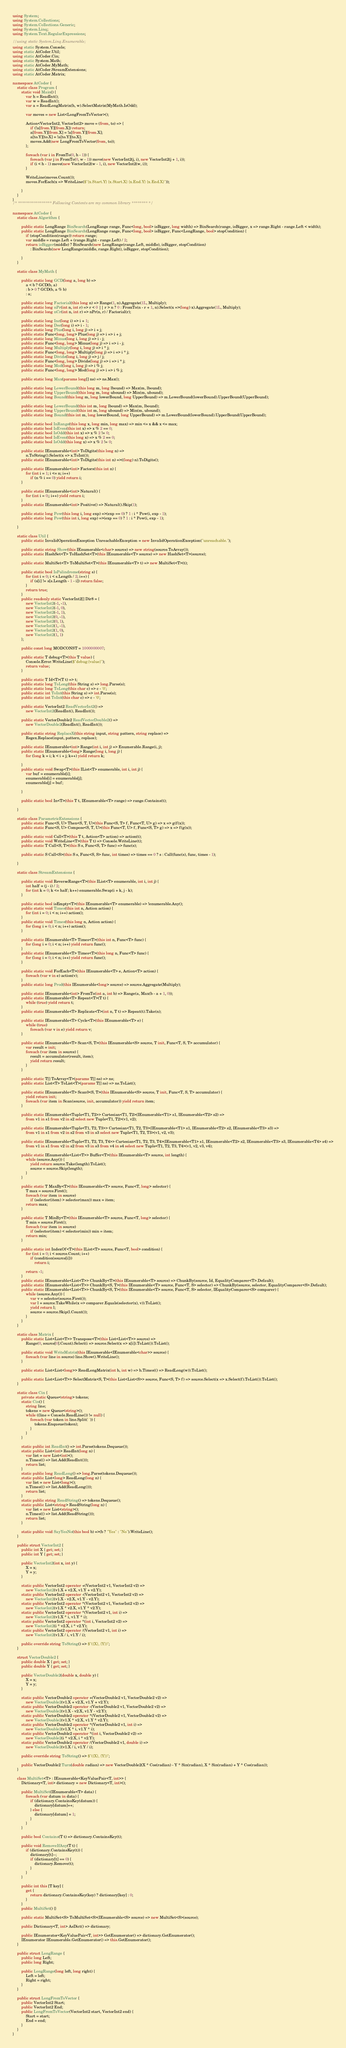<code> <loc_0><loc_0><loc_500><loc_500><_C#_>using System;
using System.Collections;
using System.Collections.Generic;
using System.Linq;
using System.Text.RegularExpressions;

//using static System.Linq.Enumerable;
using static System.Console;
using static AtCoder.Util;
using static AtCoder.Cin;
using static System.Math;
using static AtCoder.MyMath;
using static AtCoder.StreamExtensions;
using static AtCoder.Matrix;

namespace AtCoder {
    static class Program {
        static void Main() {
            var h = ReadInt();
            var w = ReadInt();
            var a = ReadLongMatrix(h, w).SelectMatrix(MyMath.IsOdd);

            var moves = new List<LongFromToVector>();

            Action<VectorInt2, VectorInt2> move = (from, to) => {
                if (!a[from.Y][from.X]) return;
                a[from.Y][from.X] = !a[from.Y][from.X];
                a[to.Y][to.X] = !a[to.Y][to.X];
                moves.Add(new LongFromToVector(from, to));
            };

            foreach (var i in FromTo(0, h - 1)) {
                foreach (var j in FromTo(0, w - 1)) move(new VectorInt2(j, i), new VectorInt2(j + 1, i));
                if (i < h - 1) move(new VectorInt2(w - 1, i), new VectorInt2(w, i));
            }

            WriteLine(moves.Count());
            moves.ForEach(x => WriteLine($"{x.Start.Y} {x.Start.X} {x.End.Y} {x.End.X}"));

        }
    }
}
/* ***************** Following Contents are my common library ******** */

namespace AtCoder {
    static class Algorithm {

        public static LongRange BinSearch(LongRange range, Func<long, bool> isBigger, long width) => BinSearch(range, isBigger, x => range.Right - range.Left < width);
        public static LongRange BinSearch(LongRange range, Func<long, bool> isBigger, Func<LongRange, bool> stopCondition) {
            if (stopCondition(range)) return range;
            var middle = range.Left + (range.Right - range.Left) / 2;
            return isBigger(middle) ? BinSearch(new LongRange(range.Left, middle), isBigger, stopCondition)
                : BinSearch(new LongRange(middle, range.Right), isBigger, stopCondition);

        }
    }

    static class MyMath {

        public static long GCD(long a, long b) =>
            a < b ? GCD(b, a)
            : b > 0 ? GCD(b, a % b)
            : a;

        public static long Factorial(this long n) => Range(1, n).Aggregate(1L, Multiply);
        public static long nPr(int n, int r) => r < 0 || r > n ? 0 : FromTo(n - r + 1, n).Select(x =>(long) x).Aggregate(1L, Multiply);
        public static long nCr(int n, int r) => nPr(n, r) / Factorial(r);

        public static long Inc(long i) => i + 1;
        public static long Dec(long i) => i - 1;
        public static long Plus(long i, long j) => i + j;
        public static Func<long, long> Plus(long j) => i => i + j;
        public static long Minus(long i, long j) => i - j;
        public static Func<long, long> Minus(long j) => i => i - j;
        public static long Multiply(long i, long j) => i * j;
        public static Func<long, long> Multiply(long j) => i => i * j;
        public static long Divide(long i, long j) => j / j;
        public static Func<long, long> Divide(long j) => i => i * j;
        public static long Mod(long i, long j) => i % j;
        public static Func<long, long> Mod(long j) => i => i % j;

        public static long Max(params long[] ns) => ns.Max();

        public static long LowerBound(this long m, long lbound) => Max(m, lbound);
        public static long UpperBound(this long m, long ubound) => Min(m, ubound);
        public static long Bound(this long m, long lowerBound, long UpperBound) => m.LowerBound(lowerBound).UpperBound(UpperBound);

        public static long LowerBound(this int m, long lbound) => Max(m, lbound);
        public static long UpperBound(this int m, long ubound) => Min(m, ubound);
        public static long Bound(this int m, long lowerBound, long UpperBound) => m.LowerBound(lowerBound).UpperBound(UpperBound);

        public static bool InRange(this long x, long min, long max) => min <= x && x <= max;
        public static bool IsEven(this int x) => x % 2 == 0;
        public static bool IsOdd(this int x) => x % 2 != 0;
        public static bool IsEven(this long x) => x % 2 == 0;
        public static bool IsOdd(this long x) => x % 2 != 0;

        public static IEnumerable<int> ToDigits(this long n) =>
            n.ToString().Select(x => x.ToInt());
        public static IEnumerable<int> ToDigits(this int n) =>((long) n).ToDigits();

        public static IEnumerable<int> Factors(this int n) {
            for (int i = 1; i <= n; i++)
                if (n % i == 0) yield return i;
        }

        public static IEnumerable<int> Natural() {
            for (int i = 0;; i++) yield return i;
        }
        public static IEnumerable<int> Positive() => Natural().Skip(1);

        public static long Pow(this long i, long exp) =>(exp == 0) ? 1 : i * Pow(i, exp - 1);
        public static long Pow(this int i, long exp) =>(exp == 0) ? 1 : i * Pow(i, exp - 1);

    }

    static class Util {
        public static InvalidOperationException UnreachableException = new InvalidOperationException("unreachable.");

        public static string Show(this IEnumerable<char> source) => new string(source.ToArray());
        public static HashSet<T> ToHashSet<T>(this IEnumerable<T> source) => new HashSet<T>(source);

        public static MultiSet<T> ToMultiSet<T>(this IEnumerable<T> t) => new MultiSet<T>(t);

        public static bool IsPalindrome(string s) {
            for (int i = 0; i < s.Length / 2; i++) {
                if (s[i] != s[s.Length - 1 - i]) return false;
            }
            return true;
        }
        public readonly static VectorInt2[] Dir8 = {
            new VectorInt2(-1, -1),
            new VectorInt2(-1, 0),
            new VectorInt2(-1, 1),
            new VectorInt2(0, -1),
            new VectorInt2(0, 1),
            new VectorInt2(1, -1),
            new VectorInt2(1, 0),
            new VectorInt2(1, 1)
        };

        public const long MODCONST = 1000000007;

        public static T debug<T>(this T value) {
            Console.Error.WriteLine($"debug:{value}");
            return value;
        }

        public static T Id<T>(T t) => t;
        public static long ToLong(this String s) => long.Parse(s);
        public static long ToLong(this char c) => c - '0';
        public static int ToInt(this String s) => int.Parse(s);
        public static int ToInt(this char c) => c - '0';

        public static VectorInt2 ReadVectorInt2() =>
            new VectorInt2(ReadInt(), ReadInt());

        public static VectorDouble2 ReadVectorDouble2() =>
            new VectorDouble2(ReadInt(), ReadInt());

        public static string ReplaceX(this string input, string pattern, string replace) =>
            Regex.Replace(input, pattern, replace);

        public static IEnumerable<int> Range(int i, int j) => Enumerable.Range(i, j);
        public static IEnumerable<long> Range(long i, long j) {
            for (long k = i; k < i + j; k++) yield return k;

        }
        public static void Swap<T>(this IList<T> enumerable, int i, int j) {
            var buf = enumerable[i];
            enumerable[i] = enumerable[j];
            enumerable[j] = buf;

        }

        public static bool In<T>(this T t, IEnumerable<T> range) => range.Contains(t);

    }

    static class ParametricExtensions {
        public static Func<S, U> Then<S, T, U>(this Func<S, T> f, Func<T, U> g) => x => g(f(x));
        public static Func<S, U> Compose<S, T, U>(this Func<T, U> f, Func<S, T> g) => x => f(g(x));

        public static void Call<T>(this T t, Action<T> action) => action(t);
        public static void WriteLine<T>(this T t) => Console.WriteLine(t);
        public static T Call<S, T>(this S s, Func<S, T> func) => func(s);

        public static S Call<S>(this S s, Func<S, S> func, int times) => times == 0 ? s : Call(func(s), func, times - 1);

    }

    static class StreamExtensions {

        public static void ReverseRange<T>(this IList<T> enumerable, int i, int j) {
            int half = (j - i) / 2;
            for (int k = 0; k <= half; k++) enumerable.Swap(i + k, j - k);
        }

        public static bool isEmpty<T>(this IEnumerable<T> enumerable) => !enumerable.Any();
        public static void Times(this int n, Action action) {
            for (int i = 0; i < n; i++) action();
        }
        public static void Times(this long n, Action action) {
            for (long i = 0; i < n; i++) action();
        }

        public static IEnumerable<T> Times<T>(this int n, Func<T> func) {
            for (long i = 0; i < n; i++) yield return func();
        }
        public static IEnumerable<T> Times<T>(this long n, Func<T> func) {
            for (long i = 0; i < n; i++) yield return func();
        }

        public static void ForEach<T>(this IEnumerable<T> e, Action<T> action) {
            foreach (var v in e) action(v);
        }
        public static long Prod(this IEnumerable<long> source) => source.Aggregate(Multiply);

        public static IEnumerable<int> FromTo(int a, int b) => Range(a, Max(b - a + 1, 0));
        public static IEnumerable<T> Repeat<T>(T t) {
            while (true) yield return t;
        }
        public static IEnumerable<T> Replicate<T>(int n, T t) => Repeat(t).Take(n);

        public static IEnumerable<T> Cycle<T>(this IEnumerable<T> e) {
            while (true)
                foreach (var v in e) yield return v;
        }

        public static IEnumerable<T> Scan<S, T>(this IEnumerable<S> source, T init, Func<T, S, T> accumulator) {
            var result = init;
            foreach (var item in source) {
                result = accumulator(result, item);
                yield return result;
            }
        }

        public static T[] ToArray<T>(params T[] ns) => ns;
        public static List<T> ToList<T>(params T[] ns) => ns.ToList();

        public static IEnumerable<T> Scan0<S, T>(this IEnumerable<S> source, T init, Func<T, S, T> accumulator) {
            yield return init;
            foreach (var item in Scan(source, init, accumulator)) yield return item;
        }

        public static IEnumerable<Tuple<T1, T2>> Cartesian<T1, T2>(IEnumerable<T1> s1, IEnumerable<T2> s2) =>
            from v1 in s1 from v2 in s2 select new Tuple<T1, T2>(v1, v2);

        public static IEnumerable<Tuple<T1, T2, T3>> Cartesian<T1, T2, T3>(IEnumerable<T1> s1, IEnumerable<T2> s2, IEnumerable<T3> s3) =>
            from v1 in s1 from v2 in s2 from v3 in s3 select new Tuple<T1, T2, T3>(v1, v2, v3);

        public static IEnumerable<Tuple<T1, T2, T3, T4>> Cartesian<T1, T2, T3, T4>(IEnumerable<T1> s1, IEnumerable<T2> s2, IEnumerable<T3> s3, IEnumerable<T4> s4) =>
            from v1 in s1 from v2 in s2 from v3 in s3 from v4 in s4 select new Tuple<T1, T2, T3, T4>(v1, v2, v3, v4);

        public static IEnumerable<List<T>> Buffer<T>(this IEnumerable<T> source, int length) {
            while (source.Any()) {
                yield return source.Take(length).ToList();
                source = source.Skip(length);
            }
        }

        public static T MaxBy<T>(this IEnumerable<T> source, Func<T, long> selector) {
            T max = source.First();
            foreach (var item in source)
                if (selector(item) > selector(max)) max = item;
            return max;
        }

        public static T MinBy<T>(this IEnumerable<T> source, Func<T, long> selector) {
            T min = source.First();
            foreach (var item in source)
                if (selector(item) < selector(min)) min = item;
            return min;
        }

        public static int IndexOf<T>(this IList<T> source, Func<T, bool> condition) {
            for (int i = 0; i < source.Count; i++)
                if (condition(source[i]))
                    return i;

            return -1;
        }
        public static IEnumerable<List<T>> ChunkBy<T>(this IEnumerable<T> source) => ChunkBy(source, Id, EqualityComparer<T>.Default);
        public static IEnumerable<List<T>> ChunkBy<S, T>(this IEnumerable<T> source, Func<T, S> selector) => ChunkBy(source, selector, EqualityComparer<S>.Default);
        public static IEnumerable<List<T>> ChunkBy<S, T>(this IEnumerable<T> source, Func<T, S> selector, IEqualityComparer<S> comparer) {
            while (source.Any()) {
                var v = selector(source.First());
                var l = source.TakeWhile(x => comparer.Equals(selector(x), v)).ToList();
                yield return l;
                source = source.Skip(l.Count());
            }
        }
    }

    static class Matrix {
        public static List<List<T>> Transpose<T>(this List<List<T>> source) =>
            Range(0, source[0].Count).Select(i => source.Select(x => x[i]).ToList()).ToList();

        public static void WriteMatrix(this IEnumerable<IEnumerable<char>> source) {
            foreach (var line in source) line.Show().WriteLine();
        }

        public static List<List<long>> ReadLongMatrix(int h, int w) => h.Times(() => ReadLong(w)).ToList();

        public static List<List<T>> SelectMatrix<S, T>(this List<List<S>> source, Func<S, T> f) => source.Select(x => x.Select(f).ToList()).ToList();
    }

    static class Cin {
        private static Queue<string> tokens;
        static Cin() {
            string line;
            tokens = new Queue<string>();
            while ((line = Console.ReadLine()) != null) {
                foreach (var token in line.Split(' ')) {
                    tokens.Enqueue(token);
                }
            }
        }

        static public int ReadInt() => int.Parse(tokens.Dequeue());
        static public List<int> ReadInt(long n) {
            var list = new List<int>();
            n.Times(() => list.Add(ReadInt()));
            return list;
        }
        static public long ReadLong() => long.Parse(tokens.Dequeue());
        static public List<long> ReadLong(long n) {
            var list = new List<long>();
            n.Times(() => list.Add(ReadLong()));
            return list;
        }
        static public string ReadString() => tokens.Dequeue();
        static public List<string> ReadString(long n) {
            var list = new List<string>();
            n.Times(() => list.Add(ReadString()));
            return list;
        }

        static public void SayYesNo(this bool b) =>(b ? "Yes" : "No").WriteLine();
    }

    public struct VectorInt2 {
        public int X { get; set; }
        public int Y { get; set; }

        public VectorInt2(int x, int y) {
            X = x;
            Y = y;
        }

        static public VectorInt2 operator +(VectorInt2 v1, VectorInt2 v2) =>
            new VectorInt2(v1.X + v2.X, v1.Y + v2.Y);
        static public VectorInt2 operator -(VectorInt2 v1, VectorInt2 v2) =>
            new VectorInt2(v1.X - v2.X, v1.Y - v2.Y);
        static public VectorInt2 operator *(VectorInt2 v1, VectorInt2 v2) =>
            new VectorInt2(v1.X * v2.X, v1.Y * v2.Y);
        static public VectorInt2 operator *(VectorInt2 v1, int i) =>
            new VectorInt2(v1.X * i, v1.Y * i);
        static public VectorInt2 operator *(int i, VectorInt2 v2) =>
            new VectorInt2(i * v2.X, i * v2.Y);
        static public VectorInt2 operator /(VectorInt2 v1, int i) =>
            new VectorInt2(v1.X / i, v1.Y / i);

        public override string ToString() => $"({X}, {Y})";
    }

    struct VectorDouble2 {
        public double X { get; set; }
        public double Y { get; set; }

        public VectorDouble2(double x, double y) {
            X = x;
            Y = y;
        }

        static public VectorDouble2 operator +(VectorDouble2 v1, VectorDouble2 v2) =>
            new VectorDouble2(v1.X + v2.X, v1.Y + v2.Y);
        static public VectorDouble2 operator -(VectorDouble2 v1, VectorDouble2 v2) =>
            new VectorDouble2(v1.X - v2.X, v1.Y - v2.Y);
        static public VectorDouble2 operator *(VectorDouble2 v1, VectorDouble2 v2) =>
            new VectorDouble2(v1.X * v2.X, v1.Y * v2.Y);
        static public VectorDouble2 operator *(VectorDouble2 v1, int i) =>
            new VectorDouble2(v1.X * i, v1.Y * i);
        static public VectorDouble2 operator *(int i, VectorDouble2 v2) =>
            new VectorDouble2(i * v2.X, i * v2.Y);
        static public VectorDouble2 operator /(VectorDouble2 v1, double i) =>
            new VectorDouble2(v1.X / i, v1.Y / i);

        public override string ToString() => $"({X}, {Y})";

        public VectorDouble2 Turn(double radian) => new VectorDouble2(X * Cos(radian) - Y * Sin(radian), X * Sin(radian) + Y * Cos(radian));
    }

    class MultiSet<T> : IEnumerable<KeyValuePair<T, int>> {
        Dictionary<T, int> dictionary = new Dictionary<T, int>();

        public MultiSet(IEnumerable<T> data) {
            foreach (var datum in data) {
                if (dictionary.ContainsKey(datum)) {
                    dictionary[datum]++;
                } else {
                    dictionary[datum] = 1;
                }
            }
        }

        public bool Contains(T t) => dictionary.ContainsKey(t);

        public void RemoveIfAny(T t) {
            if (dictionary.ContainsKey(t)) {
                dictionary[t]--;
                if (dictionary[t] == 0) {
                    dictionary.Remove(t);
                }
            }
        }

        public int this [T key] {
            get {
                return dictionary.ContainsKey(key) ? dictionary[key] : 0;
            }
        }
        public MultiSet() {}

        public static MultiSet<S> ToMultiSet<S>(IEnumerable<S> source) => new MultiSet<S>(source);

        public Dictionary<T, int> AsDict() => dictionary;

        public IEnumerator<KeyValuePair<T, int>> GetEnumerator() => dictionary.GetEnumerator();
        IEnumerator IEnumerable.GetEnumerator() => this.GetEnumerator();
    }

    public struct LongRange {
        public long Left;
        public long Right;

        public LongRange(long left, long right) {
            Left = left;
            Right = right;
        }
    }

    public struct LongFromToVector {
        public VectorInt2 Start;
        public VectorInt2 End;
        public LongFromToVector(VectorInt2 start, VectorInt2 end) {
            Start = start;
            End = end;
        }
    }
}
</code> 